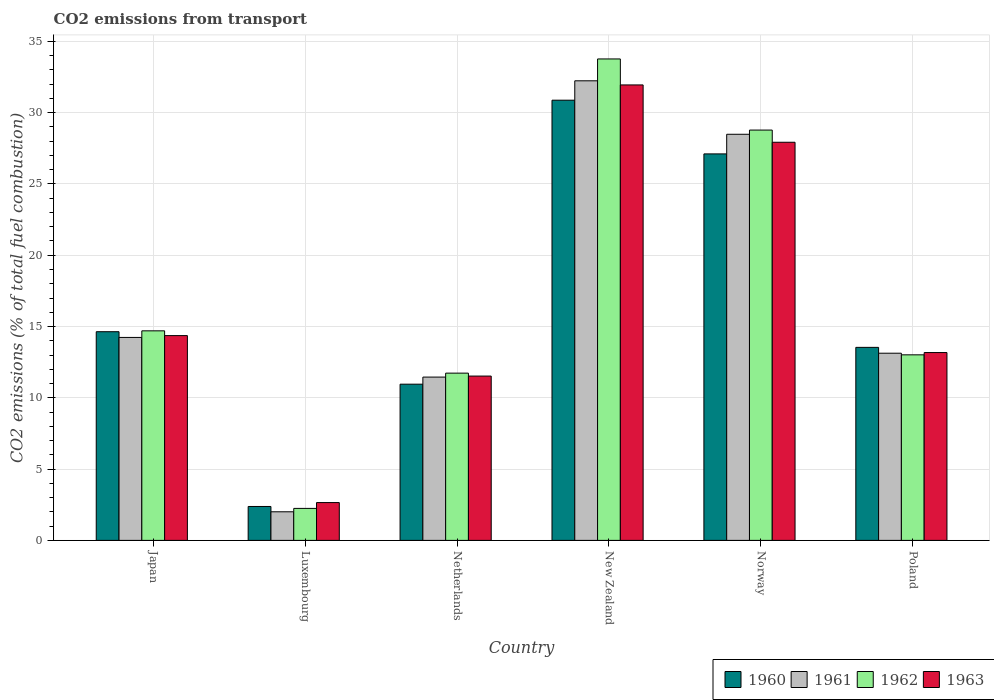Are the number of bars on each tick of the X-axis equal?
Provide a succinct answer. Yes. How many bars are there on the 4th tick from the right?
Provide a succinct answer. 4. What is the label of the 2nd group of bars from the left?
Offer a very short reply. Luxembourg. What is the total CO2 emitted in 1963 in Norway?
Your answer should be compact. 27.92. Across all countries, what is the maximum total CO2 emitted in 1963?
Ensure brevity in your answer.  31.94. Across all countries, what is the minimum total CO2 emitted in 1963?
Your answer should be very brief. 2.65. In which country was the total CO2 emitted in 1960 maximum?
Your answer should be compact. New Zealand. In which country was the total CO2 emitted in 1961 minimum?
Provide a succinct answer. Luxembourg. What is the total total CO2 emitted in 1961 in the graph?
Give a very brief answer. 101.54. What is the difference between the total CO2 emitted in 1960 in Japan and that in Poland?
Make the answer very short. 1.1. What is the difference between the total CO2 emitted in 1962 in Japan and the total CO2 emitted in 1963 in Netherlands?
Provide a short and direct response. 3.17. What is the average total CO2 emitted in 1963 per country?
Offer a terse response. 16.93. What is the difference between the total CO2 emitted of/in 1961 and total CO2 emitted of/in 1962 in Luxembourg?
Offer a very short reply. -0.24. What is the ratio of the total CO2 emitted in 1962 in Luxembourg to that in Netherlands?
Offer a terse response. 0.19. Is the total CO2 emitted in 1962 in Netherlands less than that in Norway?
Your response must be concise. Yes. Is the difference between the total CO2 emitted in 1961 in Japan and Poland greater than the difference between the total CO2 emitted in 1962 in Japan and Poland?
Offer a very short reply. No. What is the difference between the highest and the second highest total CO2 emitted in 1961?
Your answer should be very brief. 3.75. What is the difference between the highest and the lowest total CO2 emitted in 1961?
Ensure brevity in your answer.  30.23. In how many countries, is the total CO2 emitted in 1960 greater than the average total CO2 emitted in 1960 taken over all countries?
Your answer should be compact. 2. How many bars are there?
Make the answer very short. 24. Are the values on the major ticks of Y-axis written in scientific E-notation?
Your answer should be compact. No. Does the graph contain any zero values?
Offer a terse response. No. How are the legend labels stacked?
Offer a very short reply. Horizontal. What is the title of the graph?
Offer a very short reply. CO2 emissions from transport. What is the label or title of the Y-axis?
Ensure brevity in your answer.  CO2 emissions (% of total fuel combustion). What is the CO2 emissions (% of total fuel combustion) of 1960 in Japan?
Offer a very short reply. 14.64. What is the CO2 emissions (% of total fuel combustion) in 1961 in Japan?
Your response must be concise. 14.23. What is the CO2 emissions (% of total fuel combustion) in 1962 in Japan?
Ensure brevity in your answer.  14.7. What is the CO2 emissions (% of total fuel combustion) of 1963 in Japan?
Your answer should be very brief. 14.36. What is the CO2 emissions (% of total fuel combustion) of 1960 in Luxembourg?
Provide a short and direct response. 2.38. What is the CO2 emissions (% of total fuel combustion) of 1961 in Luxembourg?
Your response must be concise. 2.01. What is the CO2 emissions (% of total fuel combustion) in 1962 in Luxembourg?
Keep it short and to the point. 2.24. What is the CO2 emissions (% of total fuel combustion) of 1963 in Luxembourg?
Keep it short and to the point. 2.65. What is the CO2 emissions (% of total fuel combustion) in 1960 in Netherlands?
Your answer should be very brief. 10.96. What is the CO2 emissions (% of total fuel combustion) of 1961 in Netherlands?
Offer a very short reply. 11.45. What is the CO2 emissions (% of total fuel combustion) in 1962 in Netherlands?
Offer a very short reply. 11.73. What is the CO2 emissions (% of total fuel combustion) in 1963 in Netherlands?
Your answer should be very brief. 11.53. What is the CO2 emissions (% of total fuel combustion) in 1960 in New Zealand?
Offer a terse response. 30.87. What is the CO2 emissions (% of total fuel combustion) in 1961 in New Zealand?
Keep it short and to the point. 32.23. What is the CO2 emissions (% of total fuel combustion) of 1962 in New Zealand?
Offer a terse response. 33.77. What is the CO2 emissions (% of total fuel combustion) of 1963 in New Zealand?
Your answer should be compact. 31.94. What is the CO2 emissions (% of total fuel combustion) in 1960 in Norway?
Ensure brevity in your answer.  27.11. What is the CO2 emissions (% of total fuel combustion) in 1961 in Norway?
Provide a succinct answer. 28.48. What is the CO2 emissions (% of total fuel combustion) of 1962 in Norway?
Offer a very short reply. 28.78. What is the CO2 emissions (% of total fuel combustion) of 1963 in Norway?
Ensure brevity in your answer.  27.92. What is the CO2 emissions (% of total fuel combustion) in 1960 in Poland?
Offer a very short reply. 13.54. What is the CO2 emissions (% of total fuel combustion) in 1961 in Poland?
Your response must be concise. 13.13. What is the CO2 emissions (% of total fuel combustion) in 1962 in Poland?
Your answer should be compact. 13.01. What is the CO2 emissions (% of total fuel combustion) in 1963 in Poland?
Offer a very short reply. 13.17. Across all countries, what is the maximum CO2 emissions (% of total fuel combustion) in 1960?
Offer a terse response. 30.87. Across all countries, what is the maximum CO2 emissions (% of total fuel combustion) of 1961?
Provide a short and direct response. 32.23. Across all countries, what is the maximum CO2 emissions (% of total fuel combustion) in 1962?
Provide a succinct answer. 33.77. Across all countries, what is the maximum CO2 emissions (% of total fuel combustion) in 1963?
Offer a terse response. 31.94. Across all countries, what is the minimum CO2 emissions (% of total fuel combustion) of 1960?
Give a very brief answer. 2.38. Across all countries, what is the minimum CO2 emissions (% of total fuel combustion) in 1961?
Provide a short and direct response. 2.01. Across all countries, what is the minimum CO2 emissions (% of total fuel combustion) in 1962?
Your answer should be compact. 2.24. Across all countries, what is the minimum CO2 emissions (% of total fuel combustion) in 1963?
Make the answer very short. 2.65. What is the total CO2 emissions (% of total fuel combustion) in 1960 in the graph?
Provide a succinct answer. 99.49. What is the total CO2 emissions (% of total fuel combustion) of 1961 in the graph?
Provide a short and direct response. 101.54. What is the total CO2 emissions (% of total fuel combustion) in 1962 in the graph?
Your response must be concise. 104.23. What is the total CO2 emissions (% of total fuel combustion) in 1963 in the graph?
Your answer should be very brief. 101.58. What is the difference between the CO2 emissions (% of total fuel combustion) in 1960 in Japan and that in Luxembourg?
Give a very brief answer. 12.26. What is the difference between the CO2 emissions (% of total fuel combustion) of 1961 in Japan and that in Luxembourg?
Make the answer very short. 12.23. What is the difference between the CO2 emissions (% of total fuel combustion) of 1962 in Japan and that in Luxembourg?
Keep it short and to the point. 12.45. What is the difference between the CO2 emissions (% of total fuel combustion) in 1963 in Japan and that in Luxembourg?
Ensure brevity in your answer.  11.71. What is the difference between the CO2 emissions (% of total fuel combustion) in 1960 in Japan and that in Netherlands?
Your answer should be compact. 3.68. What is the difference between the CO2 emissions (% of total fuel combustion) of 1961 in Japan and that in Netherlands?
Make the answer very short. 2.78. What is the difference between the CO2 emissions (% of total fuel combustion) in 1962 in Japan and that in Netherlands?
Your response must be concise. 2.97. What is the difference between the CO2 emissions (% of total fuel combustion) in 1963 in Japan and that in Netherlands?
Ensure brevity in your answer.  2.84. What is the difference between the CO2 emissions (% of total fuel combustion) of 1960 in Japan and that in New Zealand?
Offer a very short reply. -16.24. What is the difference between the CO2 emissions (% of total fuel combustion) in 1961 in Japan and that in New Zealand?
Your answer should be very brief. -18. What is the difference between the CO2 emissions (% of total fuel combustion) in 1962 in Japan and that in New Zealand?
Provide a succinct answer. -19.07. What is the difference between the CO2 emissions (% of total fuel combustion) in 1963 in Japan and that in New Zealand?
Provide a succinct answer. -17.58. What is the difference between the CO2 emissions (% of total fuel combustion) of 1960 in Japan and that in Norway?
Give a very brief answer. -12.47. What is the difference between the CO2 emissions (% of total fuel combustion) in 1961 in Japan and that in Norway?
Your answer should be compact. -14.25. What is the difference between the CO2 emissions (% of total fuel combustion) of 1962 in Japan and that in Norway?
Your answer should be very brief. -14.08. What is the difference between the CO2 emissions (% of total fuel combustion) in 1963 in Japan and that in Norway?
Your response must be concise. -13.56. What is the difference between the CO2 emissions (% of total fuel combustion) of 1960 in Japan and that in Poland?
Offer a very short reply. 1.1. What is the difference between the CO2 emissions (% of total fuel combustion) of 1961 in Japan and that in Poland?
Ensure brevity in your answer.  1.11. What is the difference between the CO2 emissions (% of total fuel combustion) in 1962 in Japan and that in Poland?
Provide a succinct answer. 1.68. What is the difference between the CO2 emissions (% of total fuel combustion) in 1963 in Japan and that in Poland?
Provide a short and direct response. 1.19. What is the difference between the CO2 emissions (% of total fuel combustion) in 1960 in Luxembourg and that in Netherlands?
Your answer should be very brief. -8.58. What is the difference between the CO2 emissions (% of total fuel combustion) of 1961 in Luxembourg and that in Netherlands?
Offer a very short reply. -9.45. What is the difference between the CO2 emissions (% of total fuel combustion) of 1962 in Luxembourg and that in Netherlands?
Offer a terse response. -9.49. What is the difference between the CO2 emissions (% of total fuel combustion) of 1963 in Luxembourg and that in Netherlands?
Provide a short and direct response. -8.87. What is the difference between the CO2 emissions (% of total fuel combustion) of 1960 in Luxembourg and that in New Zealand?
Your answer should be very brief. -28.5. What is the difference between the CO2 emissions (% of total fuel combustion) of 1961 in Luxembourg and that in New Zealand?
Give a very brief answer. -30.23. What is the difference between the CO2 emissions (% of total fuel combustion) of 1962 in Luxembourg and that in New Zealand?
Provide a short and direct response. -31.52. What is the difference between the CO2 emissions (% of total fuel combustion) of 1963 in Luxembourg and that in New Zealand?
Offer a terse response. -29.29. What is the difference between the CO2 emissions (% of total fuel combustion) of 1960 in Luxembourg and that in Norway?
Offer a terse response. -24.73. What is the difference between the CO2 emissions (% of total fuel combustion) of 1961 in Luxembourg and that in Norway?
Make the answer very short. -26.48. What is the difference between the CO2 emissions (% of total fuel combustion) of 1962 in Luxembourg and that in Norway?
Ensure brevity in your answer.  -26.53. What is the difference between the CO2 emissions (% of total fuel combustion) of 1963 in Luxembourg and that in Norway?
Provide a short and direct response. -25.27. What is the difference between the CO2 emissions (% of total fuel combustion) in 1960 in Luxembourg and that in Poland?
Your answer should be compact. -11.16. What is the difference between the CO2 emissions (% of total fuel combustion) of 1961 in Luxembourg and that in Poland?
Offer a terse response. -11.12. What is the difference between the CO2 emissions (% of total fuel combustion) in 1962 in Luxembourg and that in Poland?
Ensure brevity in your answer.  -10.77. What is the difference between the CO2 emissions (% of total fuel combustion) of 1963 in Luxembourg and that in Poland?
Provide a succinct answer. -10.52. What is the difference between the CO2 emissions (% of total fuel combustion) of 1960 in Netherlands and that in New Zealand?
Offer a terse response. -19.92. What is the difference between the CO2 emissions (% of total fuel combustion) of 1961 in Netherlands and that in New Zealand?
Give a very brief answer. -20.78. What is the difference between the CO2 emissions (% of total fuel combustion) in 1962 in Netherlands and that in New Zealand?
Provide a short and direct response. -22.04. What is the difference between the CO2 emissions (% of total fuel combustion) of 1963 in Netherlands and that in New Zealand?
Your response must be concise. -20.42. What is the difference between the CO2 emissions (% of total fuel combustion) in 1960 in Netherlands and that in Norway?
Offer a very short reply. -16.15. What is the difference between the CO2 emissions (% of total fuel combustion) in 1961 in Netherlands and that in Norway?
Offer a very short reply. -17.03. What is the difference between the CO2 emissions (% of total fuel combustion) of 1962 in Netherlands and that in Norway?
Provide a succinct answer. -17.05. What is the difference between the CO2 emissions (% of total fuel combustion) of 1963 in Netherlands and that in Norway?
Your answer should be very brief. -16.4. What is the difference between the CO2 emissions (% of total fuel combustion) in 1960 in Netherlands and that in Poland?
Provide a short and direct response. -2.58. What is the difference between the CO2 emissions (% of total fuel combustion) in 1961 in Netherlands and that in Poland?
Your response must be concise. -1.67. What is the difference between the CO2 emissions (% of total fuel combustion) in 1962 in Netherlands and that in Poland?
Give a very brief answer. -1.28. What is the difference between the CO2 emissions (% of total fuel combustion) of 1963 in Netherlands and that in Poland?
Make the answer very short. -1.65. What is the difference between the CO2 emissions (% of total fuel combustion) of 1960 in New Zealand and that in Norway?
Your answer should be compact. 3.77. What is the difference between the CO2 emissions (% of total fuel combustion) in 1961 in New Zealand and that in Norway?
Your answer should be compact. 3.75. What is the difference between the CO2 emissions (% of total fuel combustion) of 1962 in New Zealand and that in Norway?
Keep it short and to the point. 4.99. What is the difference between the CO2 emissions (% of total fuel combustion) in 1963 in New Zealand and that in Norway?
Give a very brief answer. 4.02. What is the difference between the CO2 emissions (% of total fuel combustion) in 1960 in New Zealand and that in Poland?
Your response must be concise. 17.34. What is the difference between the CO2 emissions (% of total fuel combustion) in 1961 in New Zealand and that in Poland?
Keep it short and to the point. 19.11. What is the difference between the CO2 emissions (% of total fuel combustion) of 1962 in New Zealand and that in Poland?
Provide a short and direct response. 20.75. What is the difference between the CO2 emissions (% of total fuel combustion) in 1963 in New Zealand and that in Poland?
Provide a short and direct response. 18.77. What is the difference between the CO2 emissions (% of total fuel combustion) of 1960 in Norway and that in Poland?
Provide a short and direct response. 13.57. What is the difference between the CO2 emissions (% of total fuel combustion) in 1961 in Norway and that in Poland?
Your response must be concise. 15.36. What is the difference between the CO2 emissions (% of total fuel combustion) in 1962 in Norway and that in Poland?
Offer a very short reply. 15.76. What is the difference between the CO2 emissions (% of total fuel combustion) of 1963 in Norway and that in Poland?
Your answer should be very brief. 14.75. What is the difference between the CO2 emissions (% of total fuel combustion) in 1960 in Japan and the CO2 emissions (% of total fuel combustion) in 1961 in Luxembourg?
Your response must be concise. 12.63. What is the difference between the CO2 emissions (% of total fuel combustion) in 1960 in Japan and the CO2 emissions (% of total fuel combustion) in 1962 in Luxembourg?
Your answer should be compact. 12.39. What is the difference between the CO2 emissions (% of total fuel combustion) of 1960 in Japan and the CO2 emissions (% of total fuel combustion) of 1963 in Luxembourg?
Keep it short and to the point. 11.98. What is the difference between the CO2 emissions (% of total fuel combustion) in 1961 in Japan and the CO2 emissions (% of total fuel combustion) in 1962 in Luxembourg?
Make the answer very short. 11.99. What is the difference between the CO2 emissions (% of total fuel combustion) in 1961 in Japan and the CO2 emissions (% of total fuel combustion) in 1963 in Luxembourg?
Give a very brief answer. 11.58. What is the difference between the CO2 emissions (% of total fuel combustion) in 1962 in Japan and the CO2 emissions (% of total fuel combustion) in 1963 in Luxembourg?
Offer a terse response. 12.05. What is the difference between the CO2 emissions (% of total fuel combustion) of 1960 in Japan and the CO2 emissions (% of total fuel combustion) of 1961 in Netherlands?
Keep it short and to the point. 3.18. What is the difference between the CO2 emissions (% of total fuel combustion) of 1960 in Japan and the CO2 emissions (% of total fuel combustion) of 1962 in Netherlands?
Make the answer very short. 2.91. What is the difference between the CO2 emissions (% of total fuel combustion) of 1960 in Japan and the CO2 emissions (% of total fuel combustion) of 1963 in Netherlands?
Offer a very short reply. 3.11. What is the difference between the CO2 emissions (% of total fuel combustion) in 1961 in Japan and the CO2 emissions (% of total fuel combustion) in 1962 in Netherlands?
Your answer should be very brief. 2.5. What is the difference between the CO2 emissions (% of total fuel combustion) of 1961 in Japan and the CO2 emissions (% of total fuel combustion) of 1963 in Netherlands?
Make the answer very short. 2.71. What is the difference between the CO2 emissions (% of total fuel combustion) of 1962 in Japan and the CO2 emissions (% of total fuel combustion) of 1963 in Netherlands?
Provide a succinct answer. 3.17. What is the difference between the CO2 emissions (% of total fuel combustion) of 1960 in Japan and the CO2 emissions (% of total fuel combustion) of 1961 in New Zealand?
Give a very brief answer. -17.6. What is the difference between the CO2 emissions (% of total fuel combustion) of 1960 in Japan and the CO2 emissions (% of total fuel combustion) of 1962 in New Zealand?
Your answer should be very brief. -19.13. What is the difference between the CO2 emissions (% of total fuel combustion) of 1960 in Japan and the CO2 emissions (% of total fuel combustion) of 1963 in New Zealand?
Ensure brevity in your answer.  -17.31. What is the difference between the CO2 emissions (% of total fuel combustion) in 1961 in Japan and the CO2 emissions (% of total fuel combustion) in 1962 in New Zealand?
Give a very brief answer. -19.53. What is the difference between the CO2 emissions (% of total fuel combustion) in 1961 in Japan and the CO2 emissions (% of total fuel combustion) in 1963 in New Zealand?
Your answer should be compact. -17.71. What is the difference between the CO2 emissions (% of total fuel combustion) in 1962 in Japan and the CO2 emissions (% of total fuel combustion) in 1963 in New Zealand?
Ensure brevity in your answer.  -17.25. What is the difference between the CO2 emissions (% of total fuel combustion) of 1960 in Japan and the CO2 emissions (% of total fuel combustion) of 1961 in Norway?
Ensure brevity in your answer.  -13.85. What is the difference between the CO2 emissions (% of total fuel combustion) of 1960 in Japan and the CO2 emissions (% of total fuel combustion) of 1962 in Norway?
Offer a terse response. -14.14. What is the difference between the CO2 emissions (% of total fuel combustion) of 1960 in Japan and the CO2 emissions (% of total fuel combustion) of 1963 in Norway?
Keep it short and to the point. -13.29. What is the difference between the CO2 emissions (% of total fuel combustion) in 1961 in Japan and the CO2 emissions (% of total fuel combustion) in 1962 in Norway?
Give a very brief answer. -14.54. What is the difference between the CO2 emissions (% of total fuel combustion) in 1961 in Japan and the CO2 emissions (% of total fuel combustion) in 1963 in Norway?
Make the answer very short. -13.69. What is the difference between the CO2 emissions (% of total fuel combustion) in 1962 in Japan and the CO2 emissions (% of total fuel combustion) in 1963 in Norway?
Your response must be concise. -13.23. What is the difference between the CO2 emissions (% of total fuel combustion) of 1960 in Japan and the CO2 emissions (% of total fuel combustion) of 1961 in Poland?
Ensure brevity in your answer.  1.51. What is the difference between the CO2 emissions (% of total fuel combustion) of 1960 in Japan and the CO2 emissions (% of total fuel combustion) of 1962 in Poland?
Your answer should be compact. 1.62. What is the difference between the CO2 emissions (% of total fuel combustion) in 1960 in Japan and the CO2 emissions (% of total fuel combustion) in 1963 in Poland?
Ensure brevity in your answer.  1.46. What is the difference between the CO2 emissions (% of total fuel combustion) of 1961 in Japan and the CO2 emissions (% of total fuel combustion) of 1962 in Poland?
Your answer should be very brief. 1.22. What is the difference between the CO2 emissions (% of total fuel combustion) of 1961 in Japan and the CO2 emissions (% of total fuel combustion) of 1963 in Poland?
Your answer should be compact. 1.06. What is the difference between the CO2 emissions (% of total fuel combustion) of 1962 in Japan and the CO2 emissions (% of total fuel combustion) of 1963 in Poland?
Your answer should be very brief. 1.52. What is the difference between the CO2 emissions (% of total fuel combustion) of 1960 in Luxembourg and the CO2 emissions (% of total fuel combustion) of 1961 in Netherlands?
Your response must be concise. -9.08. What is the difference between the CO2 emissions (% of total fuel combustion) in 1960 in Luxembourg and the CO2 emissions (% of total fuel combustion) in 1962 in Netherlands?
Your answer should be very brief. -9.35. What is the difference between the CO2 emissions (% of total fuel combustion) of 1960 in Luxembourg and the CO2 emissions (% of total fuel combustion) of 1963 in Netherlands?
Offer a very short reply. -9.15. What is the difference between the CO2 emissions (% of total fuel combustion) in 1961 in Luxembourg and the CO2 emissions (% of total fuel combustion) in 1962 in Netherlands?
Your answer should be compact. -9.72. What is the difference between the CO2 emissions (% of total fuel combustion) in 1961 in Luxembourg and the CO2 emissions (% of total fuel combustion) in 1963 in Netherlands?
Ensure brevity in your answer.  -9.52. What is the difference between the CO2 emissions (% of total fuel combustion) of 1962 in Luxembourg and the CO2 emissions (% of total fuel combustion) of 1963 in Netherlands?
Ensure brevity in your answer.  -9.28. What is the difference between the CO2 emissions (% of total fuel combustion) of 1960 in Luxembourg and the CO2 emissions (% of total fuel combustion) of 1961 in New Zealand?
Make the answer very short. -29.86. What is the difference between the CO2 emissions (% of total fuel combustion) in 1960 in Luxembourg and the CO2 emissions (% of total fuel combustion) in 1962 in New Zealand?
Ensure brevity in your answer.  -31.39. What is the difference between the CO2 emissions (% of total fuel combustion) in 1960 in Luxembourg and the CO2 emissions (% of total fuel combustion) in 1963 in New Zealand?
Ensure brevity in your answer.  -29.57. What is the difference between the CO2 emissions (% of total fuel combustion) of 1961 in Luxembourg and the CO2 emissions (% of total fuel combustion) of 1962 in New Zealand?
Your answer should be very brief. -31.76. What is the difference between the CO2 emissions (% of total fuel combustion) in 1961 in Luxembourg and the CO2 emissions (% of total fuel combustion) in 1963 in New Zealand?
Your response must be concise. -29.94. What is the difference between the CO2 emissions (% of total fuel combustion) of 1962 in Luxembourg and the CO2 emissions (% of total fuel combustion) of 1963 in New Zealand?
Your answer should be very brief. -29.7. What is the difference between the CO2 emissions (% of total fuel combustion) in 1960 in Luxembourg and the CO2 emissions (% of total fuel combustion) in 1961 in Norway?
Keep it short and to the point. -26.1. What is the difference between the CO2 emissions (% of total fuel combustion) in 1960 in Luxembourg and the CO2 emissions (% of total fuel combustion) in 1962 in Norway?
Your answer should be compact. -26.4. What is the difference between the CO2 emissions (% of total fuel combustion) of 1960 in Luxembourg and the CO2 emissions (% of total fuel combustion) of 1963 in Norway?
Keep it short and to the point. -25.54. What is the difference between the CO2 emissions (% of total fuel combustion) of 1961 in Luxembourg and the CO2 emissions (% of total fuel combustion) of 1962 in Norway?
Your answer should be very brief. -26.77. What is the difference between the CO2 emissions (% of total fuel combustion) in 1961 in Luxembourg and the CO2 emissions (% of total fuel combustion) in 1963 in Norway?
Provide a short and direct response. -25.92. What is the difference between the CO2 emissions (% of total fuel combustion) in 1962 in Luxembourg and the CO2 emissions (% of total fuel combustion) in 1963 in Norway?
Offer a very short reply. -25.68. What is the difference between the CO2 emissions (% of total fuel combustion) in 1960 in Luxembourg and the CO2 emissions (% of total fuel combustion) in 1961 in Poland?
Your response must be concise. -10.75. What is the difference between the CO2 emissions (% of total fuel combustion) of 1960 in Luxembourg and the CO2 emissions (% of total fuel combustion) of 1962 in Poland?
Your answer should be very brief. -10.64. What is the difference between the CO2 emissions (% of total fuel combustion) of 1960 in Luxembourg and the CO2 emissions (% of total fuel combustion) of 1963 in Poland?
Your response must be concise. -10.8. What is the difference between the CO2 emissions (% of total fuel combustion) in 1961 in Luxembourg and the CO2 emissions (% of total fuel combustion) in 1962 in Poland?
Your answer should be compact. -11.01. What is the difference between the CO2 emissions (% of total fuel combustion) in 1961 in Luxembourg and the CO2 emissions (% of total fuel combustion) in 1963 in Poland?
Make the answer very short. -11.17. What is the difference between the CO2 emissions (% of total fuel combustion) in 1962 in Luxembourg and the CO2 emissions (% of total fuel combustion) in 1963 in Poland?
Your answer should be very brief. -10.93. What is the difference between the CO2 emissions (% of total fuel combustion) in 1960 in Netherlands and the CO2 emissions (% of total fuel combustion) in 1961 in New Zealand?
Offer a terse response. -21.28. What is the difference between the CO2 emissions (% of total fuel combustion) in 1960 in Netherlands and the CO2 emissions (% of total fuel combustion) in 1962 in New Zealand?
Ensure brevity in your answer.  -22.81. What is the difference between the CO2 emissions (% of total fuel combustion) of 1960 in Netherlands and the CO2 emissions (% of total fuel combustion) of 1963 in New Zealand?
Your answer should be very brief. -20.99. What is the difference between the CO2 emissions (% of total fuel combustion) in 1961 in Netherlands and the CO2 emissions (% of total fuel combustion) in 1962 in New Zealand?
Give a very brief answer. -22.31. What is the difference between the CO2 emissions (% of total fuel combustion) of 1961 in Netherlands and the CO2 emissions (% of total fuel combustion) of 1963 in New Zealand?
Your answer should be compact. -20.49. What is the difference between the CO2 emissions (% of total fuel combustion) in 1962 in Netherlands and the CO2 emissions (% of total fuel combustion) in 1963 in New Zealand?
Offer a terse response. -20.21. What is the difference between the CO2 emissions (% of total fuel combustion) in 1960 in Netherlands and the CO2 emissions (% of total fuel combustion) in 1961 in Norway?
Ensure brevity in your answer.  -17.53. What is the difference between the CO2 emissions (% of total fuel combustion) in 1960 in Netherlands and the CO2 emissions (% of total fuel combustion) in 1962 in Norway?
Provide a short and direct response. -17.82. What is the difference between the CO2 emissions (% of total fuel combustion) of 1960 in Netherlands and the CO2 emissions (% of total fuel combustion) of 1963 in Norway?
Provide a succinct answer. -16.97. What is the difference between the CO2 emissions (% of total fuel combustion) of 1961 in Netherlands and the CO2 emissions (% of total fuel combustion) of 1962 in Norway?
Offer a very short reply. -17.32. What is the difference between the CO2 emissions (% of total fuel combustion) of 1961 in Netherlands and the CO2 emissions (% of total fuel combustion) of 1963 in Norway?
Your response must be concise. -16.47. What is the difference between the CO2 emissions (% of total fuel combustion) in 1962 in Netherlands and the CO2 emissions (% of total fuel combustion) in 1963 in Norway?
Your answer should be compact. -16.19. What is the difference between the CO2 emissions (% of total fuel combustion) in 1960 in Netherlands and the CO2 emissions (% of total fuel combustion) in 1961 in Poland?
Provide a succinct answer. -2.17. What is the difference between the CO2 emissions (% of total fuel combustion) of 1960 in Netherlands and the CO2 emissions (% of total fuel combustion) of 1962 in Poland?
Your response must be concise. -2.06. What is the difference between the CO2 emissions (% of total fuel combustion) of 1960 in Netherlands and the CO2 emissions (% of total fuel combustion) of 1963 in Poland?
Offer a very short reply. -2.22. What is the difference between the CO2 emissions (% of total fuel combustion) in 1961 in Netherlands and the CO2 emissions (% of total fuel combustion) in 1962 in Poland?
Your answer should be very brief. -1.56. What is the difference between the CO2 emissions (% of total fuel combustion) of 1961 in Netherlands and the CO2 emissions (% of total fuel combustion) of 1963 in Poland?
Your answer should be compact. -1.72. What is the difference between the CO2 emissions (% of total fuel combustion) in 1962 in Netherlands and the CO2 emissions (% of total fuel combustion) in 1963 in Poland?
Your answer should be compact. -1.44. What is the difference between the CO2 emissions (% of total fuel combustion) in 1960 in New Zealand and the CO2 emissions (% of total fuel combustion) in 1961 in Norway?
Your answer should be compact. 2.39. What is the difference between the CO2 emissions (% of total fuel combustion) in 1960 in New Zealand and the CO2 emissions (% of total fuel combustion) in 1962 in Norway?
Provide a succinct answer. 2.1. What is the difference between the CO2 emissions (% of total fuel combustion) of 1960 in New Zealand and the CO2 emissions (% of total fuel combustion) of 1963 in Norway?
Your response must be concise. 2.95. What is the difference between the CO2 emissions (% of total fuel combustion) of 1961 in New Zealand and the CO2 emissions (% of total fuel combustion) of 1962 in Norway?
Offer a terse response. 3.46. What is the difference between the CO2 emissions (% of total fuel combustion) in 1961 in New Zealand and the CO2 emissions (% of total fuel combustion) in 1963 in Norway?
Provide a succinct answer. 4.31. What is the difference between the CO2 emissions (% of total fuel combustion) of 1962 in New Zealand and the CO2 emissions (% of total fuel combustion) of 1963 in Norway?
Provide a succinct answer. 5.84. What is the difference between the CO2 emissions (% of total fuel combustion) in 1960 in New Zealand and the CO2 emissions (% of total fuel combustion) in 1961 in Poland?
Offer a terse response. 17.75. What is the difference between the CO2 emissions (% of total fuel combustion) of 1960 in New Zealand and the CO2 emissions (% of total fuel combustion) of 1962 in Poland?
Your response must be concise. 17.86. What is the difference between the CO2 emissions (% of total fuel combustion) of 1960 in New Zealand and the CO2 emissions (% of total fuel combustion) of 1963 in Poland?
Provide a succinct answer. 17.7. What is the difference between the CO2 emissions (% of total fuel combustion) of 1961 in New Zealand and the CO2 emissions (% of total fuel combustion) of 1962 in Poland?
Offer a terse response. 19.22. What is the difference between the CO2 emissions (% of total fuel combustion) in 1961 in New Zealand and the CO2 emissions (% of total fuel combustion) in 1963 in Poland?
Your answer should be compact. 19.06. What is the difference between the CO2 emissions (% of total fuel combustion) of 1962 in New Zealand and the CO2 emissions (% of total fuel combustion) of 1963 in Poland?
Provide a succinct answer. 20.59. What is the difference between the CO2 emissions (% of total fuel combustion) of 1960 in Norway and the CO2 emissions (% of total fuel combustion) of 1961 in Poland?
Ensure brevity in your answer.  13.98. What is the difference between the CO2 emissions (% of total fuel combustion) in 1960 in Norway and the CO2 emissions (% of total fuel combustion) in 1962 in Poland?
Provide a succinct answer. 14.09. What is the difference between the CO2 emissions (% of total fuel combustion) in 1960 in Norway and the CO2 emissions (% of total fuel combustion) in 1963 in Poland?
Provide a short and direct response. 13.93. What is the difference between the CO2 emissions (% of total fuel combustion) of 1961 in Norway and the CO2 emissions (% of total fuel combustion) of 1962 in Poland?
Offer a terse response. 15.47. What is the difference between the CO2 emissions (% of total fuel combustion) in 1961 in Norway and the CO2 emissions (% of total fuel combustion) in 1963 in Poland?
Make the answer very short. 15.31. What is the difference between the CO2 emissions (% of total fuel combustion) in 1962 in Norway and the CO2 emissions (% of total fuel combustion) in 1963 in Poland?
Your response must be concise. 15.6. What is the average CO2 emissions (% of total fuel combustion) in 1960 per country?
Give a very brief answer. 16.58. What is the average CO2 emissions (% of total fuel combustion) of 1961 per country?
Make the answer very short. 16.92. What is the average CO2 emissions (% of total fuel combustion) of 1962 per country?
Provide a succinct answer. 17.37. What is the average CO2 emissions (% of total fuel combustion) in 1963 per country?
Ensure brevity in your answer.  16.93. What is the difference between the CO2 emissions (% of total fuel combustion) in 1960 and CO2 emissions (% of total fuel combustion) in 1961 in Japan?
Your answer should be very brief. 0.4. What is the difference between the CO2 emissions (% of total fuel combustion) in 1960 and CO2 emissions (% of total fuel combustion) in 1962 in Japan?
Make the answer very short. -0.06. What is the difference between the CO2 emissions (% of total fuel combustion) in 1960 and CO2 emissions (% of total fuel combustion) in 1963 in Japan?
Offer a terse response. 0.27. What is the difference between the CO2 emissions (% of total fuel combustion) in 1961 and CO2 emissions (% of total fuel combustion) in 1962 in Japan?
Offer a terse response. -0.46. What is the difference between the CO2 emissions (% of total fuel combustion) in 1961 and CO2 emissions (% of total fuel combustion) in 1963 in Japan?
Offer a terse response. -0.13. What is the difference between the CO2 emissions (% of total fuel combustion) of 1962 and CO2 emissions (% of total fuel combustion) of 1963 in Japan?
Offer a very short reply. 0.33. What is the difference between the CO2 emissions (% of total fuel combustion) in 1960 and CO2 emissions (% of total fuel combustion) in 1961 in Luxembourg?
Ensure brevity in your answer.  0.37. What is the difference between the CO2 emissions (% of total fuel combustion) of 1960 and CO2 emissions (% of total fuel combustion) of 1962 in Luxembourg?
Provide a succinct answer. 0.14. What is the difference between the CO2 emissions (% of total fuel combustion) in 1960 and CO2 emissions (% of total fuel combustion) in 1963 in Luxembourg?
Provide a short and direct response. -0.27. What is the difference between the CO2 emissions (% of total fuel combustion) in 1961 and CO2 emissions (% of total fuel combustion) in 1962 in Luxembourg?
Your answer should be very brief. -0.24. What is the difference between the CO2 emissions (% of total fuel combustion) of 1961 and CO2 emissions (% of total fuel combustion) of 1963 in Luxembourg?
Your answer should be very brief. -0.65. What is the difference between the CO2 emissions (% of total fuel combustion) of 1962 and CO2 emissions (% of total fuel combustion) of 1963 in Luxembourg?
Ensure brevity in your answer.  -0.41. What is the difference between the CO2 emissions (% of total fuel combustion) of 1960 and CO2 emissions (% of total fuel combustion) of 1961 in Netherlands?
Keep it short and to the point. -0.5. What is the difference between the CO2 emissions (% of total fuel combustion) of 1960 and CO2 emissions (% of total fuel combustion) of 1962 in Netherlands?
Your answer should be very brief. -0.77. What is the difference between the CO2 emissions (% of total fuel combustion) in 1960 and CO2 emissions (% of total fuel combustion) in 1963 in Netherlands?
Provide a succinct answer. -0.57. What is the difference between the CO2 emissions (% of total fuel combustion) of 1961 and CO2 emissions (% of total fuel combustion) of 1962 in Netherlands?
Provide a succinct answer. -0.28. What is the difference between the CO2 emissions (% of total fuel combustion) of 1961 and CO2 emissions (% of total fuel combustion) of 1963 in Netherlands?
Offer a very short reply. -0.07. What is the difference between the CO2 emissions (% of total fuel combustion) in 1962 and CO2 emissions (% of total fuel combustion) in 1963 in Netherlands?
Provide a succinct answer. 0.21. What is the difference between the CO2 emissions (% of total fuel combustion) of 1960 and CO2 emissions (% of total fuel combustion) of 1961 in New Zealand?
Keep it short and to the point. -1.36. What is the difference between the CO2 emissions (% of total fuel combustion) in 1960 and CO2 emissions (% of total fuel combustion) in 1962 in New Zealand?
Give a very brief answer. -2.89. What is the difference between the CO2 emissions (% of total fuel combustion) in 1960 and CO2 emissions (% of total fuel combustion) in 1963 in New Zealand?
Make the answer very short. -1.07. What is the difference between the CO2 emissions (% of total fuel combustion) of 1961 and CO2 emissions (% of total fuel combustion) of 1962 in New Zealand?
Your answer should be very brief. -1.53. What is the difference between the CO2 emissions (% of total fuel combustion) in 1961 and CO2 emissions (% of total fuel combustion) in 1963 in New Zealand?
Give a very brief answer. 0.29. What is the difference between the CO2 emissions (% of total fuel combustion) of 1962 and CO2 emissions (% of total fuel combustion) of 1963 in New Zealand?
Give a very brief answer. 1.82. What is the difference between the CO2 emissions (% of total fuel combustion) of 1960 and CO2 emissions (% of total fuel combustion) of 1961 in Norway?
Keep it short and to the point. -1.38. What is the difference between the CO2 emissions (% of total fuel combustion) in 1960 and CO2 emissions (% of total fuel combustion) in 1962 in Norway?
Offer a terse response. -1.67. What is the difference between the CO2 emissions (% of total fuel combustion) in 1960 and CO2 emissions (% of total fuel combustion) in 1963 in Norway?
Offer a very short reply. -0.82. What is the difference between the CO2 emissions (% of total fuel combustion) in 1961 and CO2 emissions (% of total fuel combustion) in 1962 in Norway?
Keep it short and to the point. -0.29. What is the difference between the CO2 emissions (% of total fuel combustion) in 1961 and CO2 emissions (% of total fuel combustion) in 1963 in Norway?
Your response must be concise. 0.56. What is the difference between the CO2 emissions (% of total fuel combustion) of 1962 and CO2 emissions (% of total fuel combustion) of 1963 in Norway?
Your response must be concise. 0.85. What is the difference between the CO2 emissions (% of total fuel combustion) of 1960 and CO2 emissions (% of total fuel combustion) of 1961 in Poland?
Keep it short and to the point. 0.41. What is the difference between the CO2 emissions (% of total fuel combustion) in 1960 and CO2 emissions (% of total fuel combustion) in 1962 in Poland?
Offer a terse response. 0.52. What is the difference between the CO2 emissions (% of total fuel combustion) of 1960 and CO2 emissions (% of total fuel combustion) of 1963 in Poland?
Provide a succinct answer. 0.36. What is the difference between the CO2 emissions (% of total fuel combustion) in 1961 and CO2 emissions (% of total fuel combustion) in 1962 in Poland?
Your answer should be compact. 0.11. What is the difference between the CO2 emissions (% of total fuel combustion) in 1961 and CO2 emissions (% of total fuel combustion) in 1963 in Poland?
Ensure brevity in your answer.  -0.05. What is the difference between the CO2 emissions (% of total fuel combustion) of 1962 and CO2 emissions (% of total fuel combustion) of 1963 in Poland?
Offer a terse response. -0.16. What is the ratio of the CO2 emissions (% of total fuel combustion) in 1960 in Japan to that in Luxembourg?
Your response must be concise. 6.15. What is the ratio of the CO2 emissions (% of total fuel combustion) of 1961 in Japan to that in Luxembourg?
Your response must be concise. 7.1. What is the ratio of the CO2 emissions (% of total fuel combustion) of 1962 in Japan to that in Luxembourg?
Offer a terse response. 6.55. What is the ratio of the CO2 emissions (% of total fuel combustion) in 1963 in Japan to that in Luxembourg?
Offer a terse response. 5.41. What is the ratio of the CO2 emissions (% of total fuel combustion) of 1960 in Japan to that in Netherlands?
Your answer should be very brief. 1.34. What is the ratio of the CO2 emissions (% of total fuel combustion) of 1961 in Japan to that in Netherlands?
Your answer should be compact. 1.24. What is the ratio of the CO2 emissions (% of total fuel combustion) in 1962 in Japan to that in Netherlands?
Provide a short and direct response. 1.25. What is the ratio of the CO2 emissions (% of total fuel combustion) in 1963 in Japan to that in Netherlands?
Make the answer very short. 1.25. What is the ratio of the CO2 emissions (% of total fuel combustion) in 1960 in Japan to that in New Zealand?
Your response must be concise. 0.47. What is the ratio of the CO2 emissions (% of total fuel combustion) in 1961 in Japan to that in New Zealand?
Your answer should be compact. 0.44. What is the ratio of the CO2 emissions (% of total fuel combustion) of 1962 in Japan to that in New Zealand?
Offer a terse response. 0.44. What is the ratio of the CO2 emissions (% of total fuel combustion) of 1963 in Japan to that in New Zealand?
Your response must be concise. 0.45. What is the ratio of the CO2 emissions (% of total fuel combustion) in 1960 in Japan to that in Norway?
Make the answer very short. 0.54. What is the ratio of the CO2 emissions (% of total fuel combustion) of 1961 in Japan to that in Norway?
Provide a succinct answer. 0.5. What is the ratio of the CO2 emissions (% of total fuel combustion) in 1962 in Japan to that in Norway?
Provide a succinct answer. 0.51. What is the ratio of the CO2 emissions (% of total fuel combustion) in 1963 in Japan to that in Norway?
Offer a terse response. 0.51. What is the ratio of the CO2 emissions (% of total fuel combustion) in 1960 in Japan to that in Poland?
Keep it short and to the point. 1.08. What is the ratio of the CO2 emissions (% of total fuel combustion) of 1961 in Japan to that in Poland?
Offer a very short reply. 1.08. What is the ratio of the CO2 emissions (% of total fuel combustion) of 1962 in Japan to that in Poland?
Make the answer very short. 1.13. What is the ratio of the CO2 emissions (% of total fuel combustion) in 1963 in Japan to that in Poland?
Offer a terse response. 1.09. What is the ratio of the CO2 emissions (% of total fuel combustion) of 1960 in Luxembourg to that in Netherlands?
Ensure brevity in your answer.  0.22. What is the ratio of the CO2 emissions (% of total fuel combustion) in 1961 in Luxembourg to that in Netherlands?
Your response must be concise. 0.18. What is the ratio of the CO2 emissions (% of total fuel combustion) in 1962 in Luxembourg to that in Netherlands?
Ensure brevity in your answer.  0.19. What is the ratio of the CO2 emissions (% of total fuel combustion) of 1963 in Luxembourg to that in Netherlands?
Ensure brevity in your answer.  0.23. What is the ratio of the CO2 emissions (% of total fuel combustion) in 1960 in Luxembourg to that in New Zealand?
Provide a succinct answer. 0.08. What is the ratio of the CO2 emissions (% of total fuel combustion) in 1961 in Luxembourg to that in New Zealand?
Provide a short and direct response. 0.06. What is the ratio of the CO2 emissions (% of total fuel combustion) of 1962 in Luxembourg to that in New Zealand?
Your response must be concise. 0.07. What is the ratio of the CO2 emissions (% of total fuel combustion) of 1963 in Luxembourg to that in New Zealand?
Make the answer very short. 0.08. What is the ratio of the CO2 emissions (% of total fuel combustion) of 1960 in Luxembourg to that in Norway?
Offer a terse response. 0.09. What is the ratio of the CO2 emissions (% of total fuel combustion) of 1961 in Luxembourg to that in Norway?
Give a very brief answer. 0.07. What is the ratio of the CO2 emissions (% of total fuel combustion) of 1962 in Luxembourg to that in Norway?
Your response must be concise. 0.08. What is the ratio of the CO2 emissions (% of total fuel combustion) of 1963 in Luxembourg to that in Norway?
Provide a short and direct response. 0.1. What is the ratio of the CO2 emissions (% of total fuel combustion) of 1960 in Luxembourg to that in Poland?
Your answer should be very brief. 0.18. What is the ratio of the CO2 emissions (% of total fuel combustion) of 1961 in Luxembourg to that in Poland?
Give a very brief answer. 0.15. What is the ratio of the CO2 emissions (% of total fuel combustion) of 1962 in Luxembourg to that in Poland?
Offer a very short reply. 0.17. What is the ratio of the CO2 emissions (% of total fuel combustion) in 1963 in Luxembourg to that in Poland?
Provide a short and direct response. 0.2. What is the ratio of the CO2 emissions (% of total fuel combustion) of 1960 in Netherlands to that in New Zealand?
Offer a very short reply. 0.35. What is the ratio of the CO2 emissions (% of total fuel combustion) of 1961 in Netherlands to that in New Zealand?
Ensure brevity in your answer.  0.36. What is the ratio of the CO2 emissions (% of total fuel combustion) of 1962 in Netherlands to that in New Zealand?
Give a very brief answer. 0.35. What is the ratio of the CO2 emissions (% of total fuel combustion) in 1963 in Netherlands to that in New Zealand?
Give a very brief answer. 0.36. What is the ratio of the CO2 emissions (% of total fuel combustion) in 1960 in Netherlands to that in Norway?
Offer a very short reply. 0.4. What is the ratio of the CO2 emissions (% of total fuel combustion) of 1961 in Netherlands to that in Norway?
Offer a very short reply. 0.4. What is the ratio of the CO2 emissions (% of total fuel combustion) in 1962 in Netherlands to that in Norway?
Make the answer very short. 0.41. What is the ratio of the CO2 emissions (% of total fuel combustion) of 1963 in Netherlands to that in Norway?
Provide a succinct answer. 0.41. What is the ratio of the CO2 emissions (% of total fuel combustion) of 1960 in Netherlands to that in Poland?
Your answer should be very brief. 0.81. What is the ratio of the CO2 emissions (% of total fuel combustion) in 1961 in Netherlands to that in Poland?
Your answer should be very brief. 0.87. What is the ratio of the CO2 emissions (% of total fuel combustion) in 1962 in Netherlands to that in Poland?
Give a very brief answer. 0.9. What is the ratio of the CO2 emissions (% of total fuel combustion) in 1963 in Netherlands to that in Poland?
Offer a very short reply. 0.87. What is the ratio of the CO2 emissions (% of total fuel combustion) in 1960 in New Zealand to that in Norway?
Your answer should be very brief. 1.14. What is the ratio of the CO2 emissions (% of total fuel combustion) of 1961 in New Zealand to that in Norway?
Offer a terse response. 1.13. What is the ratio of the CO2 emissions (% of total fuel combustion) of 1962 in New Zealand to that in Norway?
Your answer should be compact. 1.17. What is the ratio of the CO2 emissions (% of total fuel combustion) of 1963 in New Zealand to that in Norway?
Offer a very short reply. 1.14. What is the ratio of the CO2 emissions (% of total fuel combustion) in 1960 in New Zealand to that in Poland?
Your answer should be very brief. 2.28. What is the ratio of the CO2 emissions (% of total fuel combustion) of 1961 in New Zealand to that in Poland?
Your response must be concise. 2.46. What is the ratio of the CO2 emissions (% of total fuel combustion) in 1962 in New Zealand to that in Poland?
Make the answer very short. 2.59. What is the ratio of the CO2 emissions (% of total fuel combustion) of 1963 in New Zealand to that in Poland?
Give a very brief answer. 2.42. What is the ratio of the CO2 emissions (% of total fuel combustion) in 1960 in Norway to that in Poland?
Your answer should be compact. 2. What is the ratio of the CO2 emissions (% of total fuel combustion) of 1961 in Norway to that in Poland?
Your answer should be very brief. 2.17. What is the ratio of the CO2 emissions (% of total fuel combustion) of 1962 in Norway to that in Poland?
Your answer should be compact. 2.21. What is the ratio of the CO2 emissions (% of total fuel combustion) in 1963 in Norway to that in Poland?
Your answer should be very brief. 2.12. What is the difference between the highest and the second highest CO2 emissions (% of total fuel combustion) in 1960?
Your answer should be compact. 3.77. What is the difference between the highest and the second highest CO2 emissions (% of total fuel combustion) of 1961?
Offer a very short reply. 3.75. What is the difference between the highest and the second highest CO2 emissions (% of total fuel combustion) of 1962?
Give a very brief answer. 4.99. What is the difference between the highest and the second highest CO2 emissions (% of total fuel combustion) in 1963?
Make the answer very short. 4.02. What is the difference between the highest and the lowest CO2 emissions (% of total fuel combustion) in 1960?
Provide a short and direct response. 28.5. What is the difference between the highest and the lowest CO2 emissions (% of total fuel combustion) in 1961?
Your response must be concise. 30.23. What is the difference between the highest and the lowest CO2 emissions (% of total fuel combustion) of 1962?
Your answer should be very brief. 31.52. What is the difference between the highest and the lowest CO2 emissions (% of total fuel combustion) in 1963?
Provide a succinct answer. 29.29. 